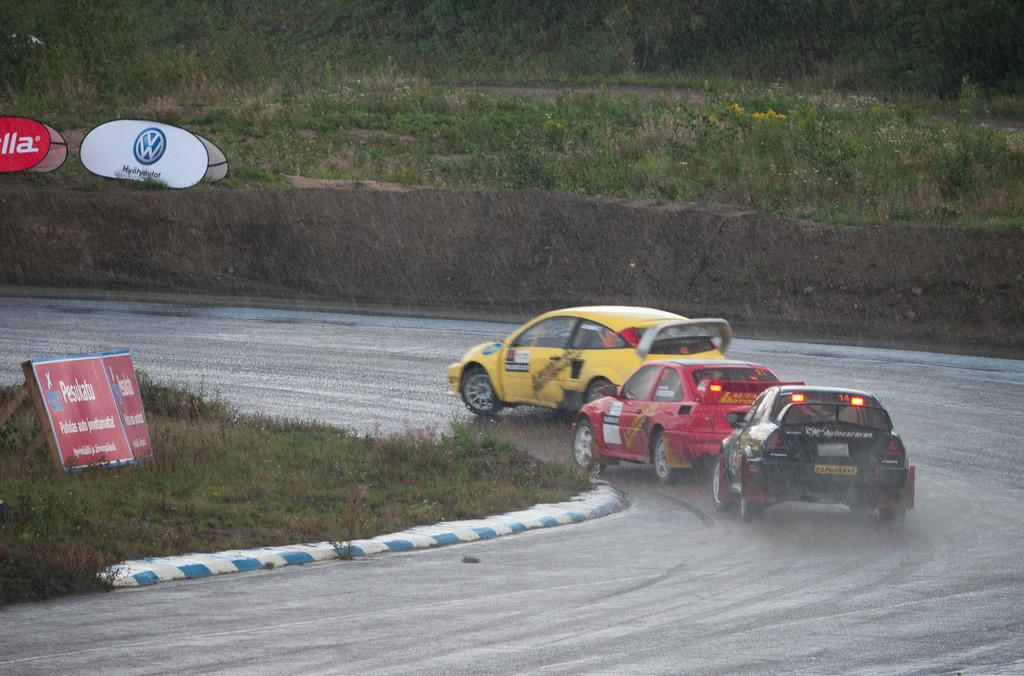How many cars are visible on the right side of the image? There are three cars on the right side of the image. What is located at the bottom of the image? There is a road and boards at the bottom of the image. What can be seen in the background of the image? There are objects, plants, and mud in the background of the image. Can you describe the insect that is fighting with the mud in the image? There is no insect present in the image, nor is there any fighting depicted. 